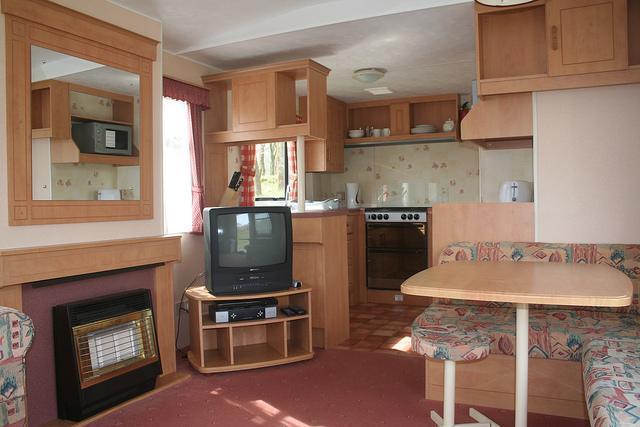How many chairs are there?
Give a very brief answer. 0. 